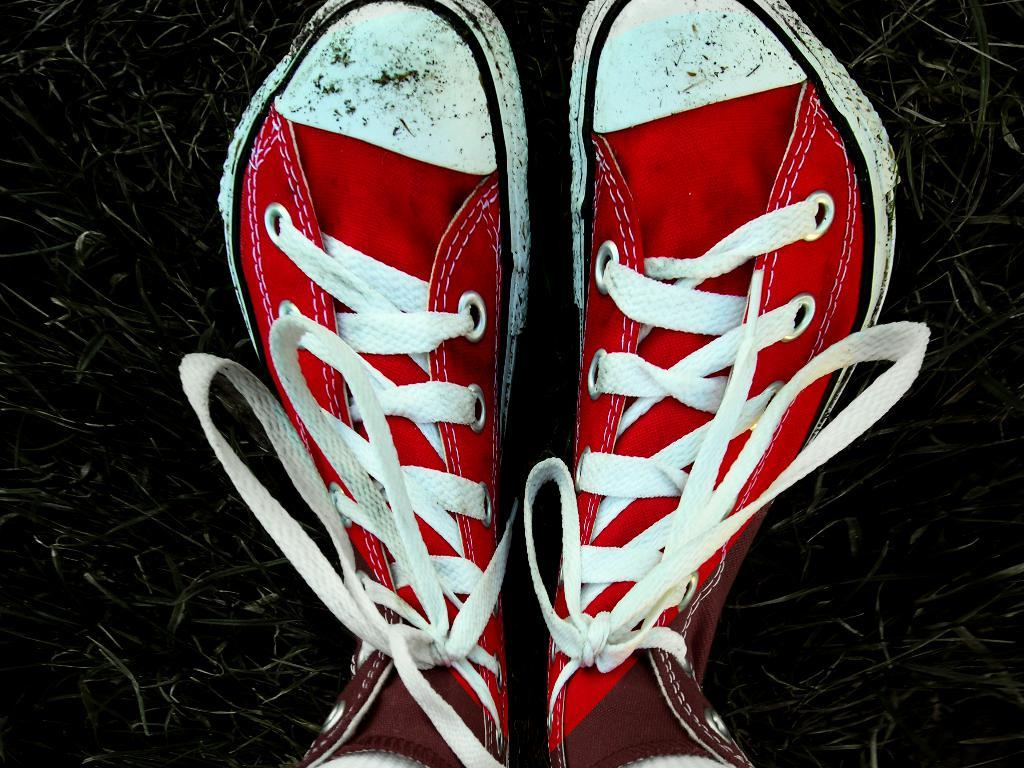What type of footwear is present in the image? There are shoes in the image. What colors are the shoes? The shoes are red and white in color. What type of natural environment is visible in the image? There is grass visible in the image. How many eyes can be seen on the shoes in the image? There are no eyes present on the shoes in the image. What type of bun is being prepared in the image? There is no bun or any food preparation visible in the image. 